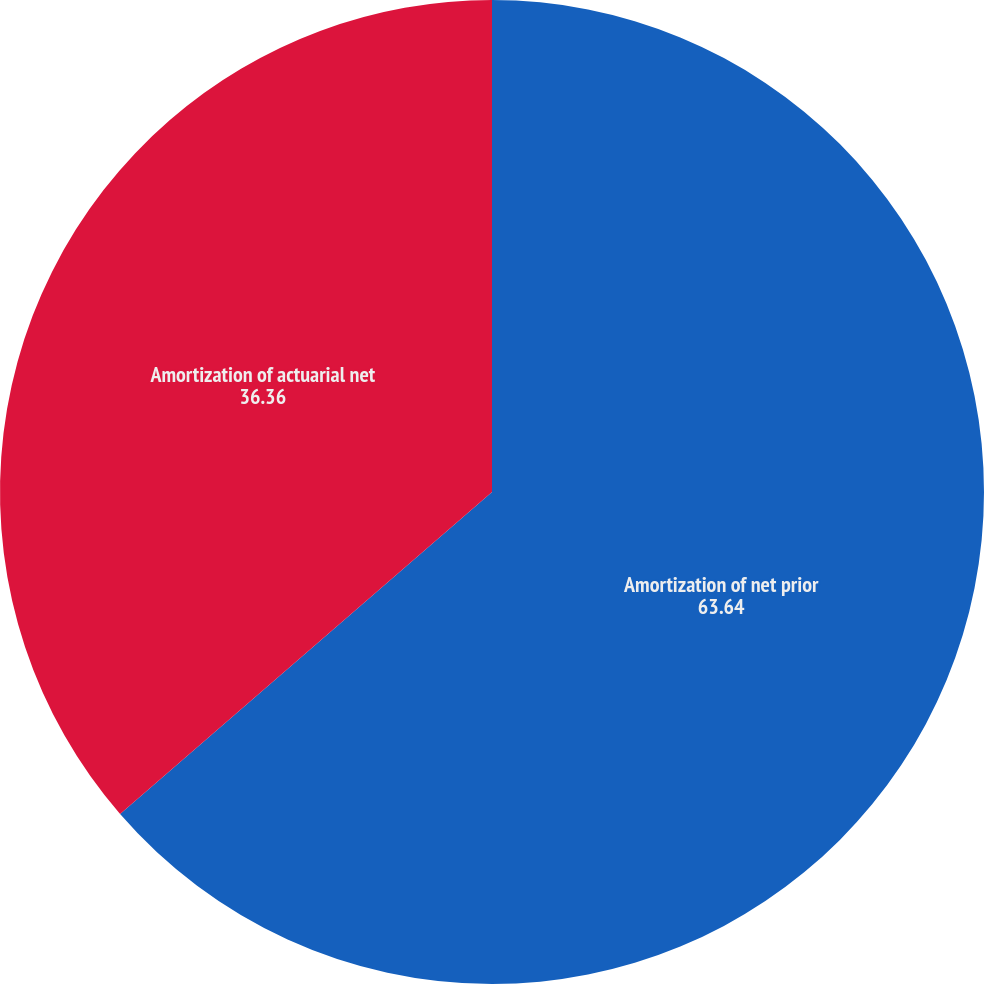Convert chart. <chart><loc_0><loc_0><loc_500><loc_500><pie_chart><fcel>Amortization of net prior<fcel>Amortization of actuarial net<nl><fcel>63.64%<fcel>36.36%<nl></chart> 